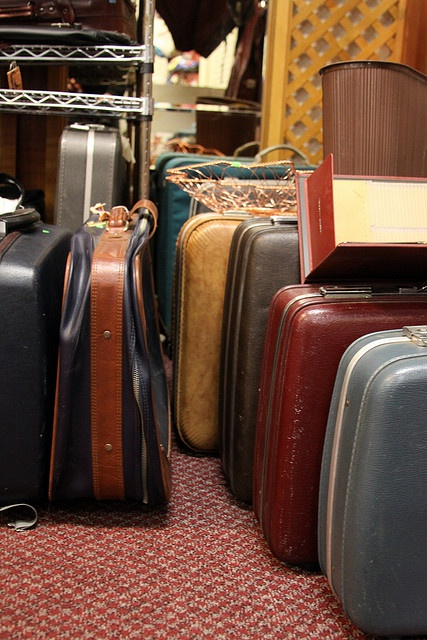Describe the objects in this image and their specific colors. I can see suitcase in black, maroon, gray, and tan tones, suitcase in maroon, gray, black, and darkgray tones, suitcase in maroon, black, brown, and gray tones, suitcase in black, gray, darkgray, and lightgray tones, and suitcase in black, maroon, and gray tones in this image. 